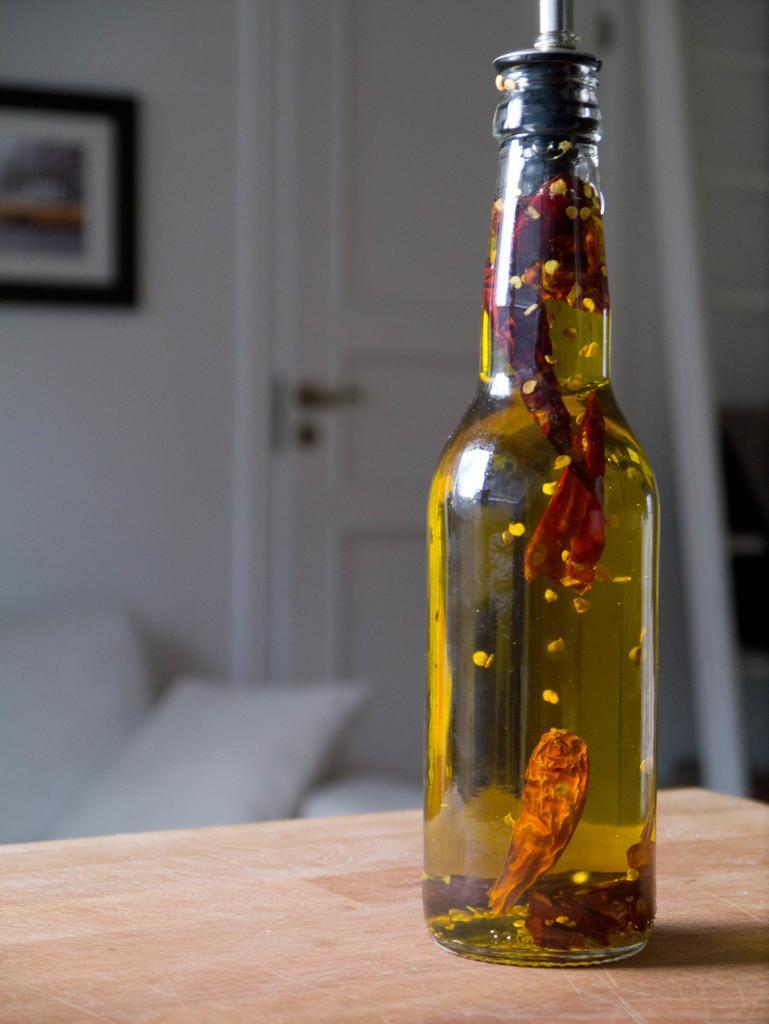How would you summarize this image in a sentence or two? In this picture we can see a bottle with full of liquid in it, and the bottle is on the table, in the background we can see a sofa and a photo frame. 